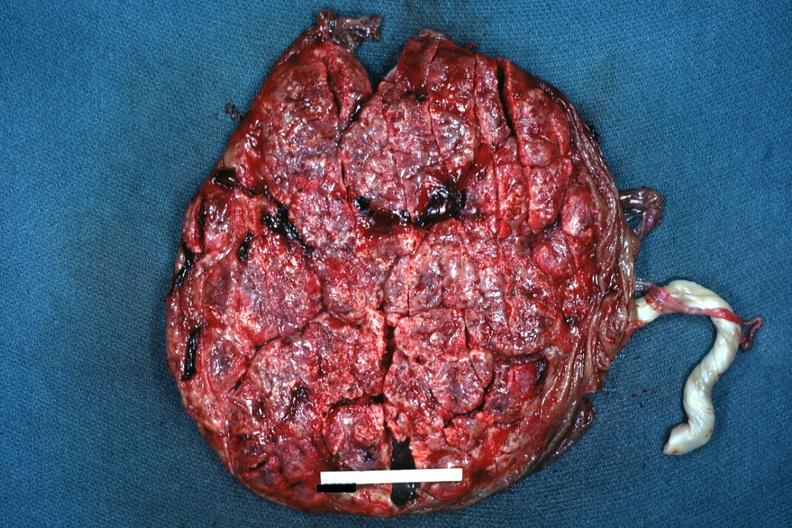s female reproductive present?
Answer the question using a single word or phrase. Yes 